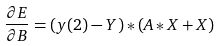<formula> <loc_0><loc_0><loc_500><loc_500>\frac { \partial E } { \partial B } = ( y ( 2 ) - Y ) * ( A * X + X )</formula> 